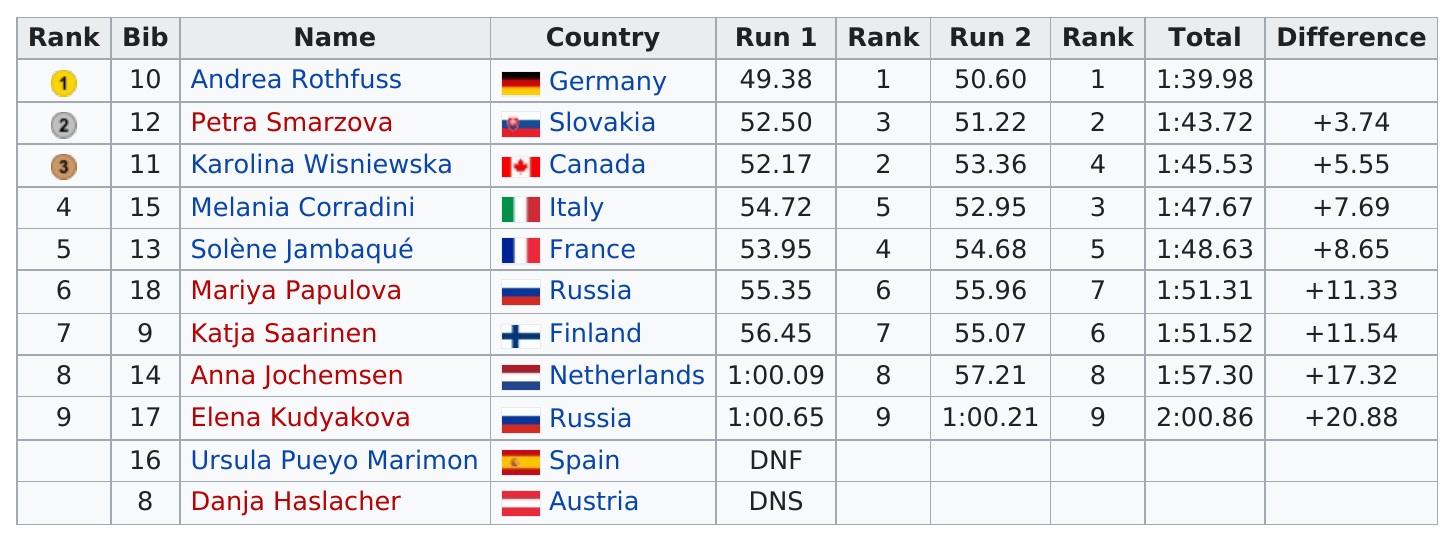Outline some significant characteristics in this image. Katja Saarinen placed above Anna Jochemsen but below Mariya Papulova in the ranking of skiiers. The difference in time between the 8th place finisher and the first place finisher was 17.32 minutes. Katja Saarinen finished directly after Papulova in the competition. Canada finished in a time of 1:45.53, followed by Italy. Out of the people who finished, 7 of them finished in less than 1:55. 